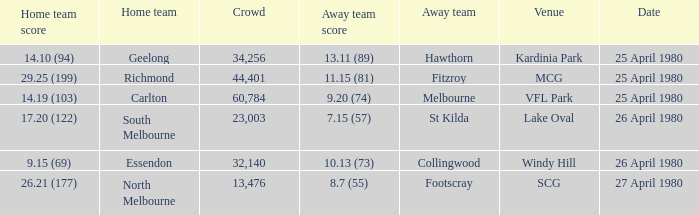On what date did the match at Lake Oval take place? 26 April 1980. 